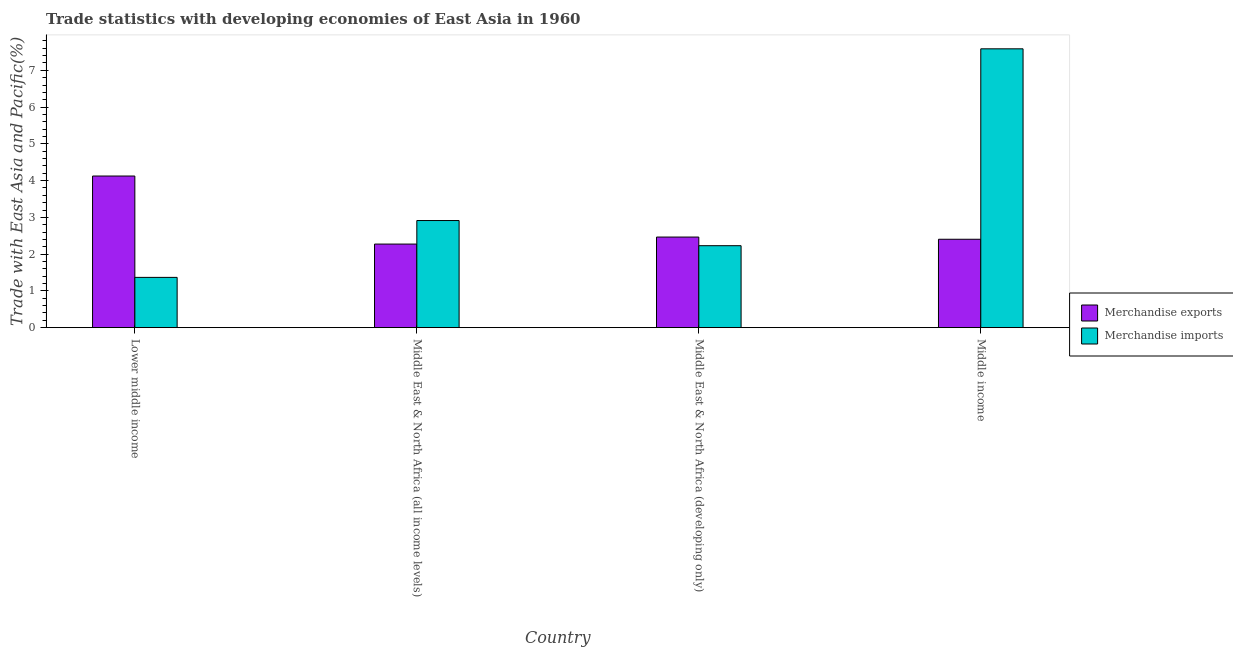How many groups of bars are there?
Ensure brevity in your answer.  4. How many bars are there on the 2nd tick from the left?
Your answer should be compact. 2. What is the label of the 3rd group of bars from the left?
Your answer should be compact. Middle East & North Africa (developing only). What is the merchandise exports in Middle East & North Africa (developing only)?
Offer a terse response. 2.46. Across all countries, what is the maximum merchandise exports?
Offer a terse response. 4.12. Across all countries, what is the minimum merchandise imports?
Offer a terse response. 1.37. In which country was the merchandise exports maximum?
Give a very brief answer. Lower middle income. In which country was the merchandise exports minimum?
Provide a succinct answer. Middle East & North Africa (all income levels). What is the total merchandise exports in the graph?
Make the answer very short. 11.27. What is the difference between the merchandise exports in Lower middle income and that in Middle East & North Africa (developing only)?
Your answer should be very brief. 1.66. What is the difference between the merchandise imports in Middle East & North Africa (developing only) and the merchandise exports in Middle East & North Africa (all income levels)?
Ensure brevity in your answer.  -0.04. What is the average merchandise imports per country?
Ensure brevity in your answer.  3.52. What is the difference between the merchandise exports and merchandise imports in Lower middle income?
Offer a terse response. 2.76. In how many countries, is the merchandise exports greater than 3.2 %?
Give a very brief answer. 1. What is the ratio of the merchandise imports in Middle East & North Africa (all income levels) to that in Middle East & North Africa (developing only)?
Your answer should be very brief. 1.31. Is the difference between the merchandise exports in Lower middle income and Middle income greater than the difference between the merchandise imports in Lower middle income and Middle income?
Keep it short and to the point. Yes. What is the difference between the highest and the second highest merchandise imports?
Offer a terse response. 4.67. What is the difference between the highest and the lowest merchandise exports?
Ensure brevity in your answer.  1.85. In how many countries, is the merchandise imports greater than the average merchandise imports taken over all countries?
Keep it short and to the point. 1. Is the sum of the merchandise imports in Middle East & North Africa (all income levels) and Middle East & North Africa (developing only) greater than the maximum merchandise exports across all countries?
Offer a very short reply. Yes. How many bars are there?
Your answer should be compact. 8. Are all the bars in the graph horizontal?
Make the answer very short. No. What is the difference between two consecutive major ticks on the Y-axis?
Your answer should be compact. 1. Are the values on the major ticks of Y-axis written in scientific E-notation?
Your response must be concise. No. How many legend labels are there?
Your answer should be very brief. 2. How are the legend labels stacked?
Your response must be concise. Vertical. What is the title of the graph?
Offer a very short reply. Trade statistics with developing economies of East Asia in 1960. Does "Birth rate" appear as one of the legend labels in the graph?
Give a very brief answer. No. What is the label or title of the X-axis?
Offer a very short reply. Country. What is the label or title of the Y-axis?
Keep it short and to the point. Trade with East Asia and Pacific(%). What is the Trade with East Asia and Pacific(%) in Merchandise exports in Lower middle income?
Keep it short and to the point. 4.12. What is the Trade with East Asia and Pacific(%) in Merchandise imports in Lower middle income?
Your answer should be very brief. 1.37. What is the Trade with East Asia and Pacific(%) of Merchandise exports in Middle East & North Africa (all income levels)?
Provide a succinct answer. 2.27. What is the Trade with East Asia and Pacific(%) in Merchandise imports in Middle East & North Africa (all income levels)?
Make the answer very short. 2.91. What is the Trade with East Asia and Pacific(%) of Merchandise exports in Middle East & North Africa (developing only)?
Offer a terse response. 2.46. What is the Trade with East Asia and Pacific(%) of Merchandise imports in Middle East & North Africa (developing only)?
Provide a short and direct response. 2.23. What is the Trade with East Asia and Pacific(%) of Merchandise exports in Middle income?
Provide a succinct answer. 2.4. What is the Trade with East Asia and Pacific(%) of Merchandise imports in Middle income?
Make the answer very short. 7.58. Across all countries, what is the maximum Trade with East Asia and Pacific(%) in Merchandise exports?
Your response must be concise. 4.12. Across all countries, what is the maximum Trade with East Asia and Pacific(%) of Merchandise imports?
Offer a terse response. 7.58. Across all countries, what is the minimum Trade with East Asia and Pacific(%) in Merchandise exports?
Keep it short and to the point. 2.27. Across all countries, what is the minimum Trade with East Asia and Pacific(%) of Merchandise imports?
Offer a very short reply. 1.37. What is the total Trade with East Asia and Pacific(%) of Merchandise exports in the graph?
Offer a terse response. 11.27. What is the total Trade with East Asia and Pacific(%) in Merchandise imports in the graph?
Give a very brief answer. 14.1. What is the difference between the Trade with East Asia and Pacific(%) of Merchandise exports in Lower middle income and that in Middle East & North Africa (all income levels)?
Your answer should be very brief. 1.85. What is the difference between the Trade with East Asia and Pacific(%) in Merchandise imports in Lower middle income and that in Middle East & North Africa (all income levels)?
Keep it short and to the point. -1.55. What is the difference between the Trade with East Asia and Pacific(%) in Merchandise exports in Lower middle income and that in Middle East & North Africa (developing only)?
Your response must be concise. 1.66. What is the difference between the Trade with East Asia and Pacific(%) in Merchandise imports in Lower middle income and that in Middle East & North Africa (developing only)?
Your answer should be compact. -0.86. What is the difference between the Trade with East Asia and Pacific(%) in Merchandise exports in Lower middle income and that in Middle income?
Offer a terse response. 1.72. What is the difference between the Trade with East Asia and Pacific(%) in Merchandise imports in Lower middle income and that in Middle income?
Provide a short and direct response. -6.22. What is the difference between the Trade with East Asia and Pacific(%) in Merchandise exports in Middle East & North Africa (all income levels) and that in Middle East & North Africa (developing only)?
Make the answer very short. -0.19. What is the difference between the Trade with East Asia and Pacific(%) in Merchandise imports in Middle East & North Africa (all income levels) and that in Middle East & North Africa (developing only)?
Make the answer very short. 0.68. What is the difference between the Trade with East Asia and Pacific(%) of Merchandise exports in Middle East & North Africa (all income levels) and that in Middle income?
Offer a very short reply. -0.13. What is the difference between the Trade with East Asia and Pacific(%) in Merchandise imports in Middle East & North Africa (all income levels) and that in Middle income?
Keep it short and to the point. -4.67. What is the difference between the Trade with East Asia and Pacific(%) of Merchandise exports in Middle East & North Africa (developing only) and that in Middle income?
Give a very brief answer. 0.06. What is the difference between the Trade with East Asia and Pacific(%) of Merchandise imports in Middle East & North Africa (developing only) and that in Middle income?
Your answer should be very brief. -5.36. What is the difference between the Trade with East Asia and Pacific(%) in Merchandise exports in Lower middle income and the Trade with East Asia and Pacific(%) in Merchandise imports in Middle East & North Africa (all income levels)?
Provide a short and direct response. 1.21. What is the difference between the Trade with East Asia and Pacific(%) of Merchandise exports in Lower middle income and the Trade with East Asia and Pacific(%) of Merchandise imports in Middle East & North Africa (developing only)?
Provide a short and direct response. 1.9. What is the difference between the Trade with East Asia and Pacific(%) in Merchandise exports in Lower middle income and the Trade with East Asia and Pacific(%) in Merchandise imports in Middle income?
Make the answer very short. -3.46. What is the difference between the Trade with East Asia and Pacific(%) in Merchandise exports in Middle East & North Africa (all income levels) and the Trade with East Asia and Pacific(%) in Merchandise imports in Middle East & North Africa (developing only)?
Your answer should be compact. 0.04. What is the difference between the Trade with East Asia and Pacific(%) in Merchandise exports in Middle East & North Africa (all income levels) and the Trade with East Asia and Pacific(%) in Merchandise imports in Middle income?
Your response must be concise. -5.31. What is the difference between the Trade with East Asia and Pacific(%) in Merchandise exports in Middle East & North Africa (developing only) and the Trade with East Asia and Pacific(%) in Merchandise imports in Middle income?
Make the answer very short. -5.12. What is the average Trade with East Asia and Pacific(%) in Merchandise exports per country?
Provide a short and direct response. 2.82. What is the average Trade with East Asia and Pacific(%) in Merchandise imports per country?
Give a very brief answer. 3.52. What is the difference between the Trade with East Asia and Pacific(%) of Merchandise exports and Trade with East Asia and Pacific(%) of Merchandise imports in Lower middle income?
Ensure brevity in your answer.  2.76. What is the difference between the Trade with East Asia and Pacific(%) in Merchandise exports and Trade with East Asia and Pacific(%) in Merchandise imports in Middle East & North Africa (all income levels)?
Make the answer very short. -0.64. What is the difference between the Trade with East Asia and Pacific(%) of Merchandise exports and Trade with East Asia and Pacific(%) of Merchandise imports in Middle East & North Africa (developing only)?
Your response must be concise. 0.23. What is the difference between the Trade with East Asia and Pacific(%) in Merchandise exports and Trade with East Asia and Pacific(%) in Merchandise imports in Middle income?
Your answer should be compact. -5.18. What is the ratio of the Trade with East Asia and Pacific(%) of Merchandise exports in Lower middle income to that in Middle East & North Africa (all income levels)?
Provide a succinct answer. 1.81. What is the ratio of the Trade with East Asia and Pacific(%) of Merchandise imports in Lower middle income to that in Middle East & North Africa (all income levels)?
Provide a short and direct response. 0.47. What is the ratio of the Trade with East Asia and Pacific(%) in Merchandise exports in Lower middle income to that in Middle East & North Africa (developing only)?
Make the answer very short. 1.67. What is the ratio of the Trade with East Asia and Pacific(%) of Merchandise imports in Lower middle income to that in Middle East & North Africa (developing only)?
Provide a short and direct response. 0.61. What is the ratio of the Trade with East Asia and Pacific(%) of Merchandise exports in Lower middle income to that in Middle income?
Provide a succinct answer. 1.72. What is the ratio of the Trade with East Asia and Pacific(%) of Merchandise imports in Lower middle income to that in Middle income?
Your response must be concise. 0.18. What is the ratio of the Trade with East Asia and Pacific(%) of Merchandise exports in Middle East & North Africa (all income levels) to that in Middle East & North Africa (developing only)?
Give a very brief answer. 0.92. What is the ratio of the Trade with East Asia and Pacific(%) in Merchandise imports in Middle East & North Africa (all income levels) to that in Middle East & North Africa (developing only)?
Your answer should be very brief. 1.31. What is the ratio of the Trade with East Asia and Pacific(%) of Merchandise exports in Middle East & North Africa (all income levels) to that in Middle income?
Keep it short and to the point. 0.95. What is the ratio of the Trade with East Asia and Pacific(%) in Merchandise imports in Middle East & North Africa (all income levels) to that in Middle income?
Provide a succinct answer. 0.38. What is the ratio of the Trade with East Asia and Pacific(%) of Merchandise exports in Middle East & North Africa (developing only) to that in Middle income?
Offer a very short reply. 1.02. What is the ratio of the Trade with East Asia and Pacific(%) of Merchandise imports in Middle East & North Africa (developing only) to that in Middle income?
Keep it short and to the point. 0.29. What is the difference between the highest and the second highest Trade with East Asia and Pacific(%) of Merchandise exports?
Provide a short and direct response. 1.66. What is the difference between the highest and the second highest Trade with East Asia and Pacific(%) of Merchandise imports?
Make the answer very short. 4.67. What is the difference between the highest and the lowest Trade with East Asia and Pacific(%) of Merchandise exports?
Provide a succinct answer. 1.85. What is the difference between the highest and the lowest Trade with East Asia and Pacific(%) in Merchandise imports?
Make the answer very short. 6.22. 